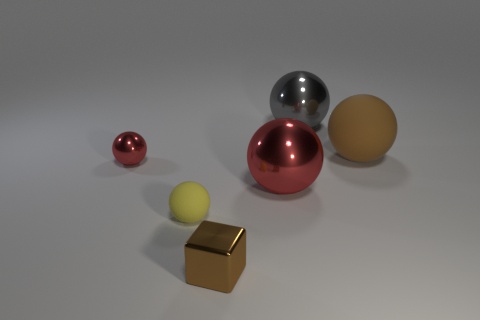What material is the big brown ball?
Your response must be concise. Rubber. What is the shape of the big object that is in front of the matte sphere behind the big metal object in front of the large brown matte object?
Make the answer very short. Sphere. What number of other objects are the same material as the gray object?
Offer a terse response. 3. Does the small red thing that is to the left of the small brown metal cube have the same material as the large object that is right of the gray shiny ball?
Give a very brief answer. No. What number of metallic objects are both behind the brown cube and right of the tiny rubber ball?
Keep it short and to the point. 2. Are there any cyan metal objects that have the same shape as the large red object?
Your response must be concise. No. What shape is the metallic object that is the same size as the shiny cube?
Your answer should be compact. Sphere. Is the number of large rubber things in front of the small yellow ball the same as the number of shiny objects that are behind the brown cube?
Offer a very short reply. No. What size is the matte sphere that is left of the brown object that is right of the gray object?
Give a very brief answer. Small. Are there any metal balls of the same size as the gray metallic thing?
Ensure brevity in your answer.  Yes. 